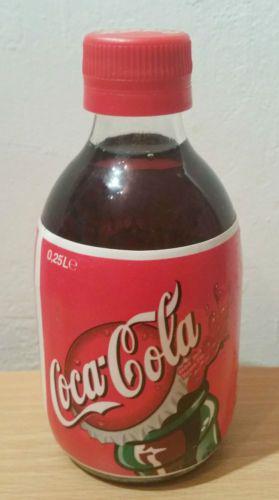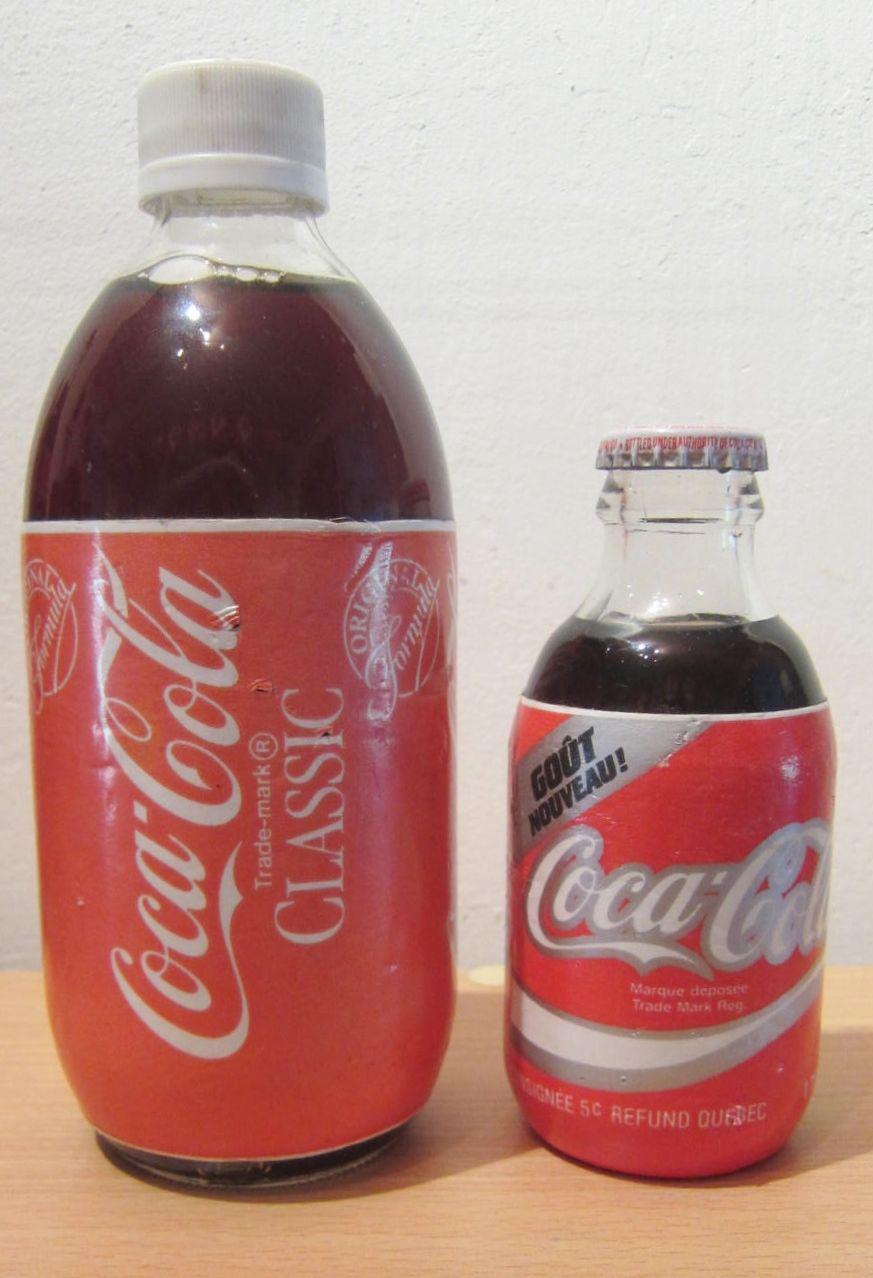The first image is the image on the left, the second image is the image on the right. Analyze the images presented: Is the assertion "There are two bottles in the image on the left and half that in the image on the right." valid? Answer yes or no. No. The first image is the image on the left, the second image is the image on the right. Evaluate the accuracy of this statement regarding the images: "All the bottles are filled with a dark liquid.". Is it true? Answer yes or no. Yes. 